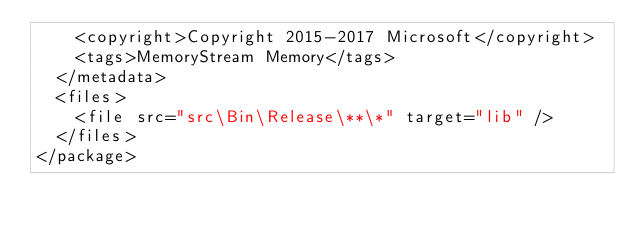<code> <loc_0><loc_0><loc_500><loc_500><_XML_>    <copyright>Copyright 2015-2017 Microsoft</copyright>
    <tags>MemoryStream Memory</tags>
  </metadata>
  <files>
    <file src="src\Bin\Release\**\*" target="lib" />
  </files>
</package>
</code> 